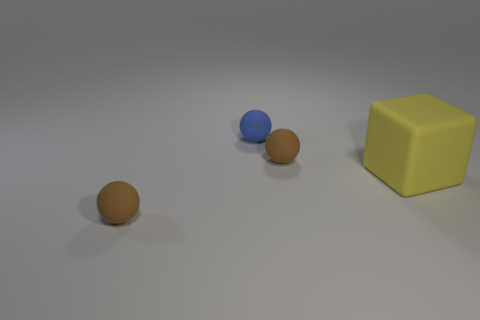Add 1 tiny purple shiny cylinders. How many objects exist? 5 Subtract all cubes. How many objects are left? 3 Subtract 0 purple cylinders. How many objects are left? 4 Subtract all rubber balls. Subtract all tiny blue matte objects. How many objects are left? 0 Add 4 brown objects. How many brown objects are left? 6 Add 4 matte objects. How many matte objects exist? 8 